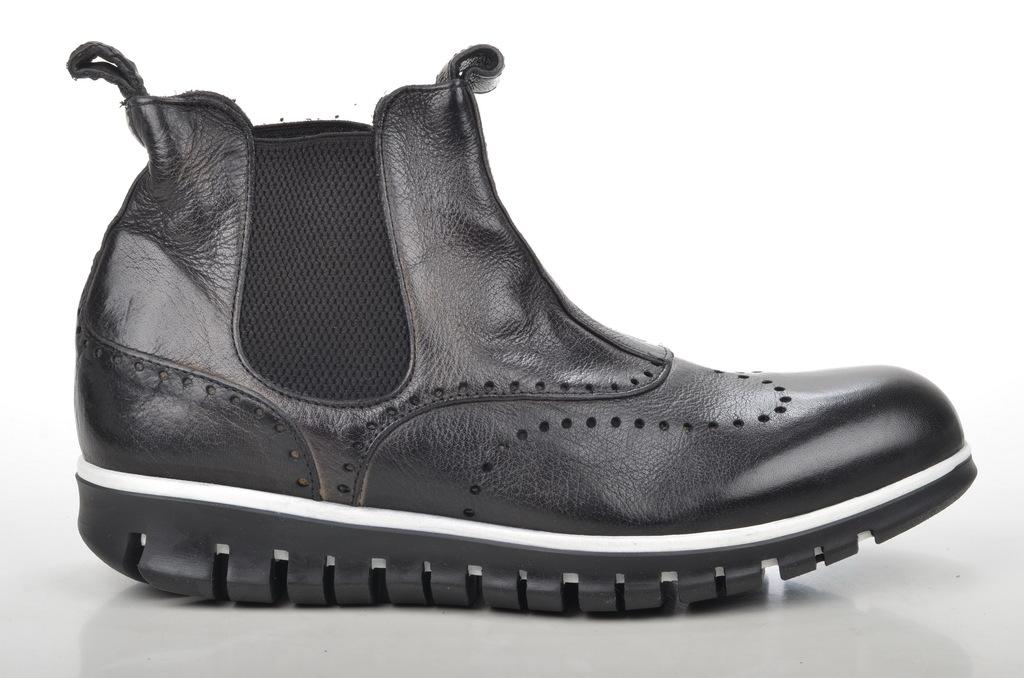What type of footwear is visible in the image? There is a black color shoe in the image. Can you describe the shoe's appearance? The shoe is black in color. What type of exchange is happening between the shoe and the person in the image? There is no exchange happening between the shoe and a person in the image; it only features a black color shoe. 